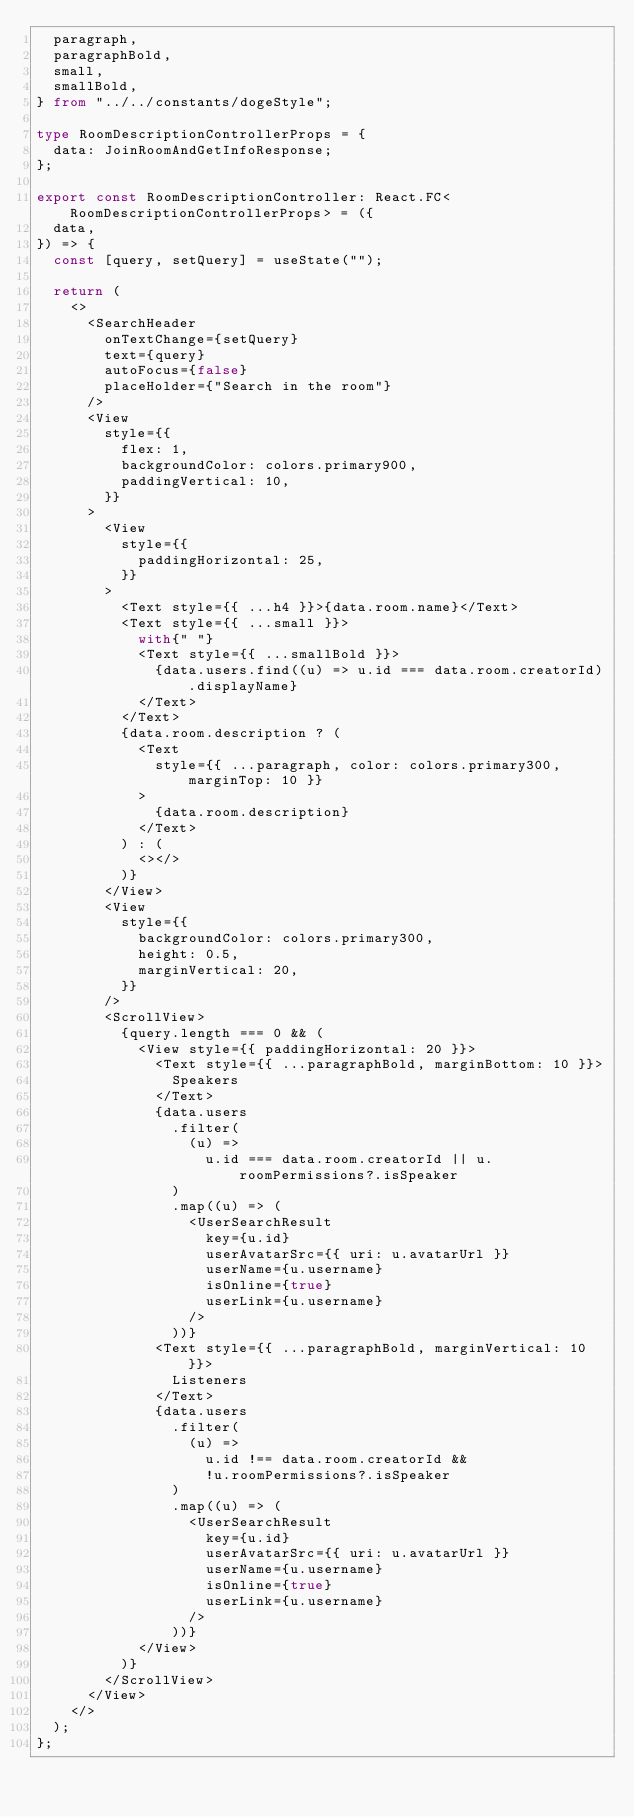<code> <loc_0><loc_0><loc_500><loc_500><_TypeScript_>  paragraph,
  paragraphBold,
  small,
  smallBold,
} from "../../constants/dogeStyle";

type RoomDescriptionControllerProps = {
  data: JoinRoomAndGetInfoResponse;
};

export const RoomDescriptionController: React.FC<RoomDescriptionControllerProps> = ({
  data,
}) => {
  const [query, setQuery] = useState("");

  return (
    <>
      <SearchHeader
        onTextChange={setQuery}
        text={query}
        autoFocus={false}
        placeHolder={"Search in the room"}
      />
      <View
        style={{
          flex: 1,
          backgroundColor: colors.primary900,
          paddingVertical: 10,
        }}
      >
        <View
          style={{
            paddingHorizontal: 25,
          }}
        >
          <Text style={{ ...h4 }}>{data.room.name}</Text>
          <Text style={{ ...small }}>
            with{" "}
            <Text style={{ ...smallBold }}>
              {data.users.find((u) => u.id === data.room.creatorId).displayName}
            </Text>
          </Text>
          {data.room.description ? (
            <Text
              style={{ ...paragraph, color: colors.primary300, marginTop: 10 }}
            >
              {data.room.description}
            </Text>
          ) : (
            <></>
          )}
        </View>
        <View
          style={{
            backgroundColor: colors.primary300,
            height: 0.5,
            marginVertical: 20,
          }}
        />
        <ScrollView>
          {query.length === 0 && (
            <View style={{ paddingHorizontal: 20 }}>
              <Text style={{ ...paragraphBold, marginBottom: 10 }}>
                Speakers
              </Text>
              {data.users
                .filter(
                  (u) =>
                    u.id === data.room.creatorId || u.roomPermissions?.isSpeaker
                )
                .map((u) => (
                  <UserSearchResult
                    key={u.id}
                    userAvatarSrc={{ uri: u.avatarUrl }}
                    userName={u.username}
                    isOnline={true}
                    userLink={u.username}
                  />
                ))}
              <Text style={{ ...paragraphBold, marginVertical: 10 }}>
                Listeners
              </Text>
              {data.users
                .filter(
                  (u) =>
                    u.id !== data.room.creatorId &&
                    !u.roomPermissions?.isSpeaker
                )
                .map((u) => (
                  <UserSearchResult
                    key={u.id}
                    userAvatarSrc={{ uri: u.avatarUrl }}
                    userName={u.username}
                    isOnline={true}
                    userLink={u.username}
                  />
                ))}
            </View>
          )}
        </ScrollView>
      </View>
    </>
  );
};
</code> 